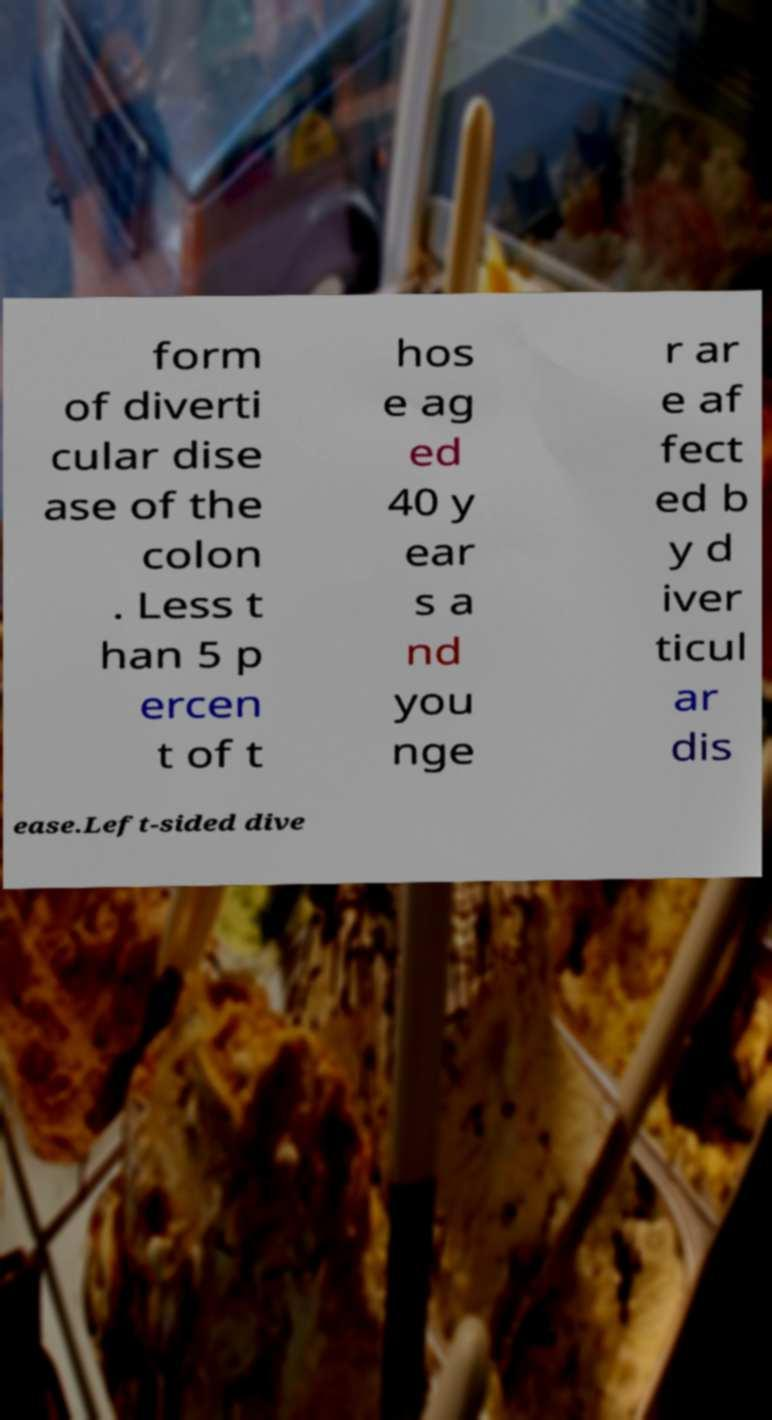What messages or text are displayed in this image? I need them in a readable, typed format. form of diverti cular dise ase of the colon . Less t han 5 p ercen t of t hos e ag ed 40 y ear s a nd you nge r ar e af fect ed b y d iver ticul ar dis ease.Left-sided dive 